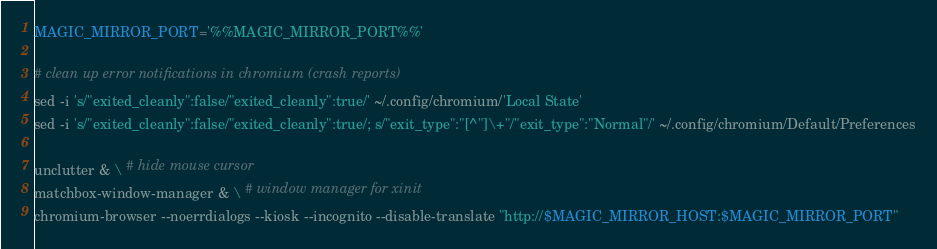Convert code to text. <code><loc_0><loc_0><loc_500><loc_500><_Bash_>MAGIC_MIRROR_PORT='%%MAGIC_MIRROR_PORT%%'

# clean up error notifications in chromium (crash reports)
sed -i 's/"exited_cleanly":false/"exited_cleanly":true/' ~/.config/chromium/'Local State'
sed -i 's/"exited_cleanly":false/"exited_cleanly":true/; s/"exit_type":"[^"]\+"/"exit_type":"Normal"/' ~/.config/chromium/Default/Preferences

unclutter & \ # hide mouse cursor
matchbox-window-manager & \ # window manager for xinit
chromium-browser --noerrdialogs --kiosk --incognito --disable-translate "http://$MAGIC_MIRROR_HOST:$MAGIC_MIRROR_PORT"
</code> 